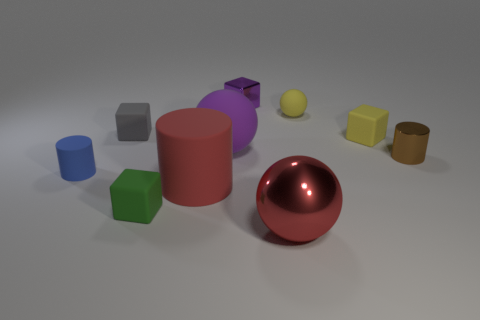Which objects in the scene are closest to the large red sphere? The objects closest to the large red sphere include a small red cylinder to the left and a small purple cube to the right. These are in close proximity to the sphere. Could you tell me the texture of these objects? Certainly, both the small red cylinder and the small purple cube appear to have a matte texture, which differs from the shiny texture of the large red sphere. 